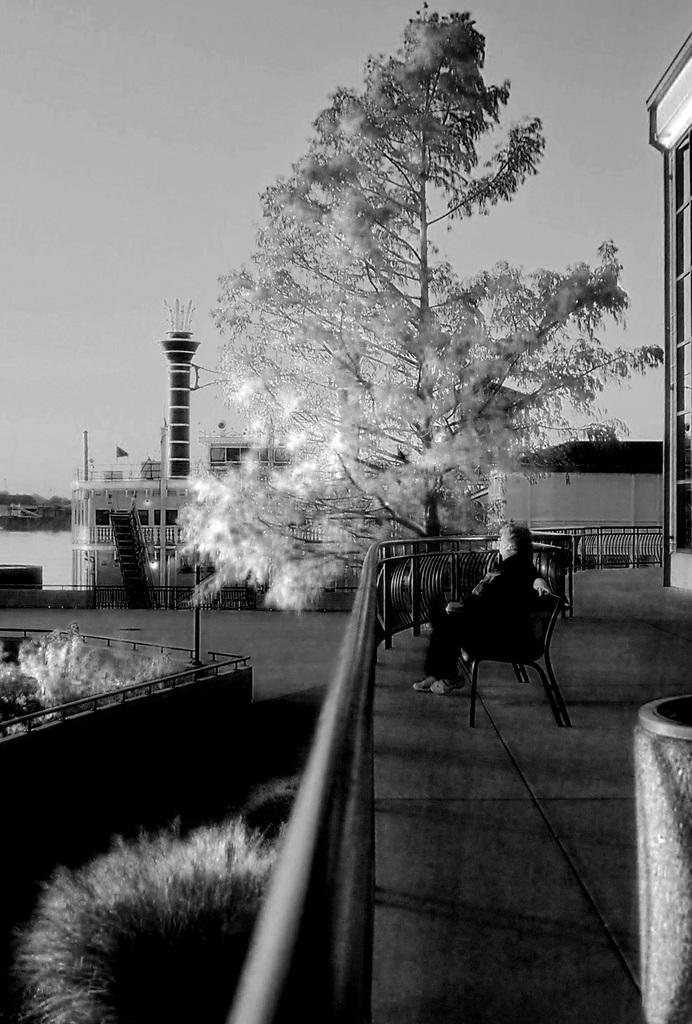What is the color scheme of the image? The image is black and white. What is the person in the image doing? The person is sitting on a bench in the image. What can be seen near the person? There are railings in the image. What type of vegetation is present in the image? Trees are present in the image. What architectural feature can be seen in the image? There is a chimney in the image. What type of structures are visible in the image? Buildings are visible in the image. What natural element is present in the image? Water is present in the image. What part of the environment is visible in the image? The sky is visible in the image. What type of veil is draped over the person sitting on the bench in the image? There is no veil present in the image; the person is simply sitting on a bench. 